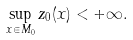<formula> <loc_0><loc_0><loc_500><loc_500>\sup _ { x \in M _ { 0 } } z _ { 0 } ( x ) < + \infty .</formula> 